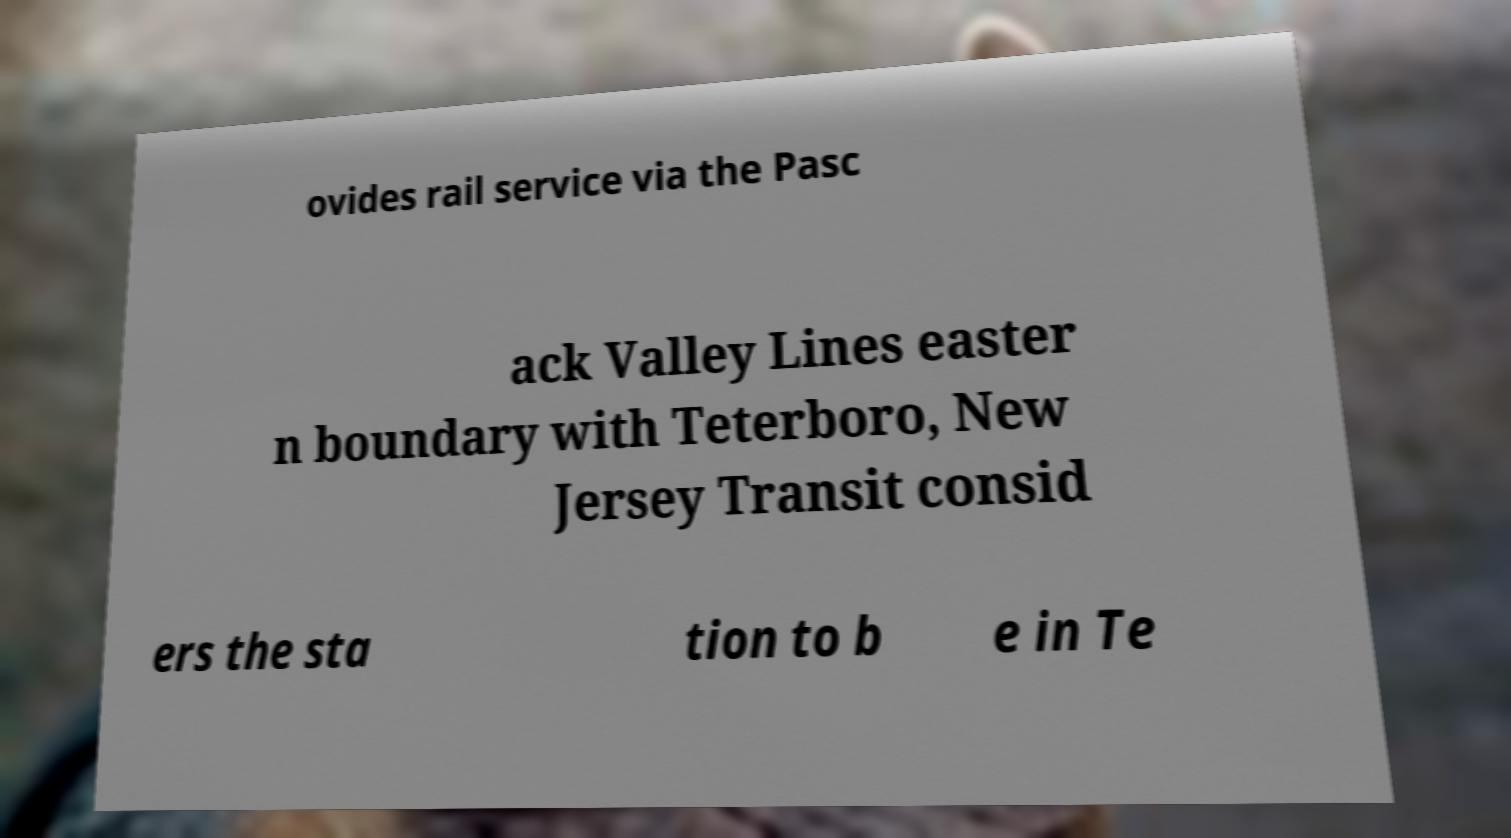Please read and relay the text visible in this image. What does it say? ovides rail service via the Pasc ack Valley Lines easter n boundary with Teterboro, New Jersey Transit consid ers the sta tion to b e in Te 